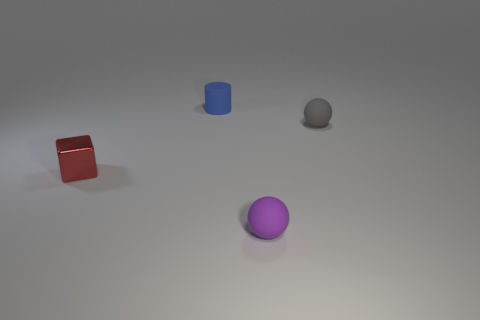Add 2 purple rubber balls. How many objects exist? 6 Subtract all cubes. How many objects are left? 3 Subtract all metallic objects. Subtract all small red objects. How many objects are left? 2 Add 3 small red metallic cubes. How many small red metallic cubes are left? 4 Add 1 cyan cylinders. How many cyan cylinders exist? 1 Subtract 0 green cubes. How many objects are left? 4 